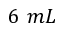<formula> <loc_0><loc_0><loc_500><loc_500>6 m L</formula> 